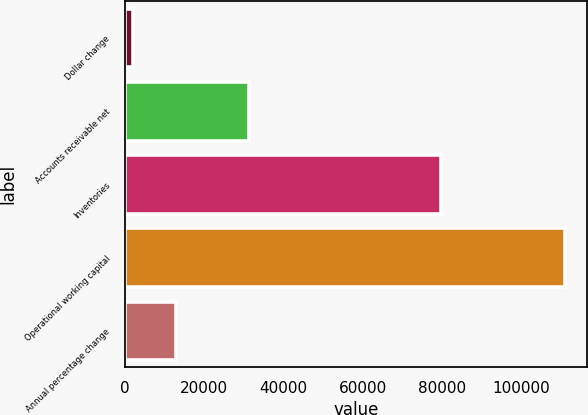<chart> <loc_0><loc_0><loc_500><loc_500><bar_chart><fcel>Dollar change<fcel>Accounts receivable net<fcel>Inventories<fcel>Operational working capital<fcel>Annual percentage change<nl><fcel>2016<fcel>31341<fcel>79726<fcel>111067<fcel>12921.1<nl></chart> 